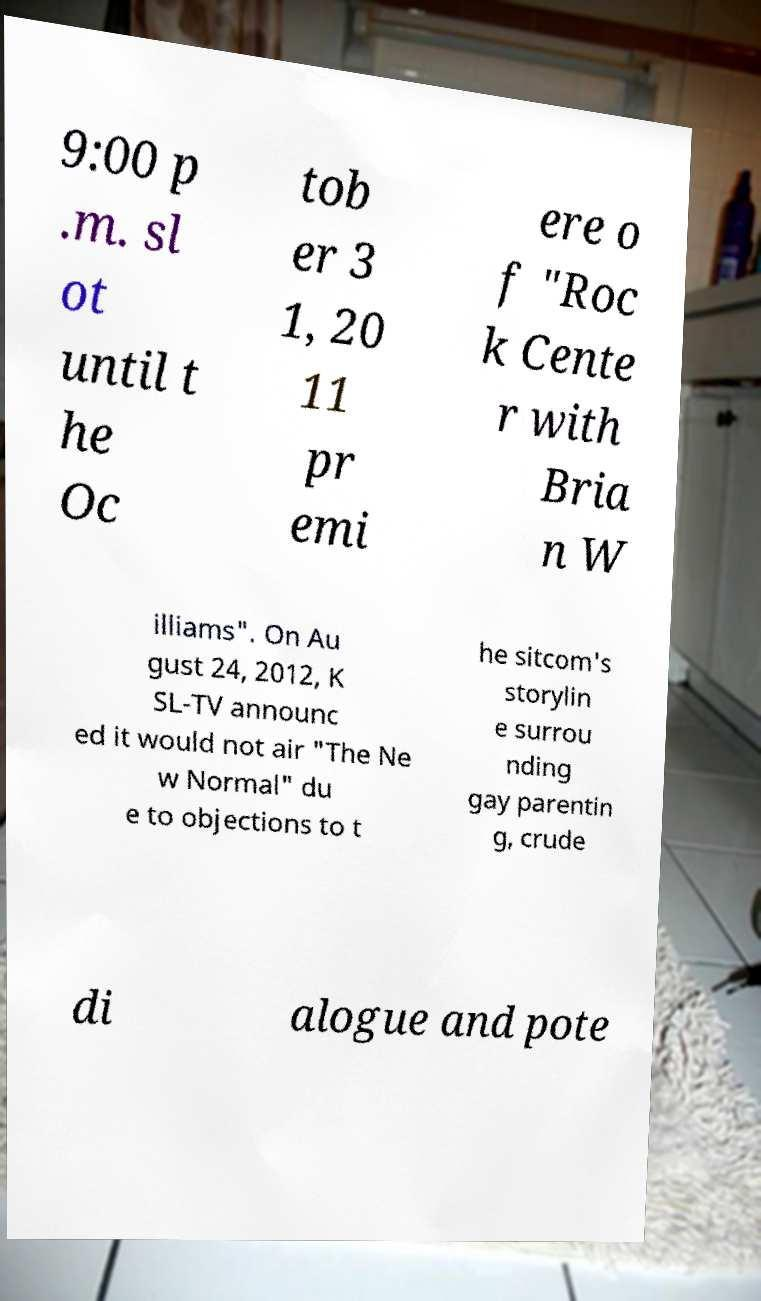Could you extract and type out the text from this image? 9:00 p .m. sl ot until t he Oc tob er 3 1, 20 11 pr emi ere o f "Roc k Cente r with Bria n W illiams". On Au gust 24, 2012, K SL-TV announc ed it would not air "The Ne w Normal" du e to objections to t he sitcom's storylin e surrou nding gay parentin g, crude di alogue and pote 